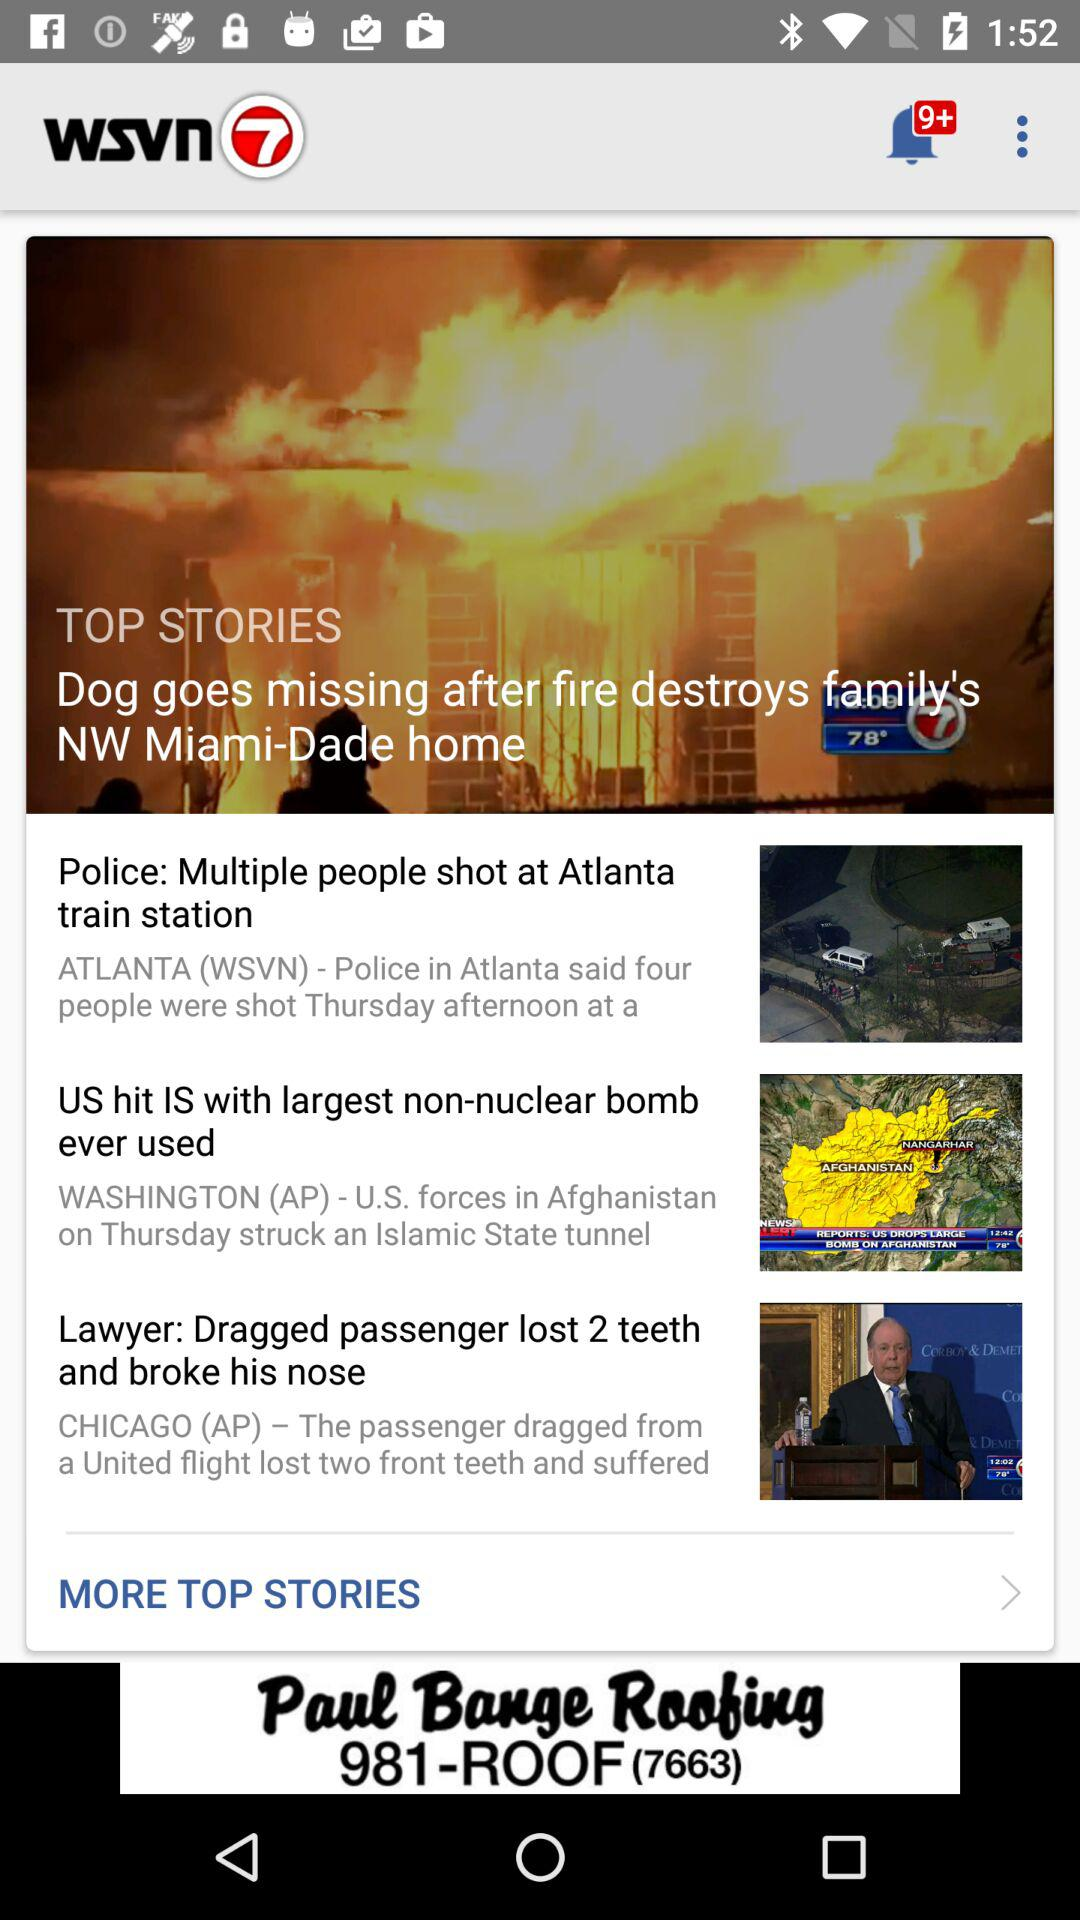What is the headline? The headlines are "Dog goes missing after fire destroys family's NW Miami-Dade home", "Police: Multiple people shot at Atlanta train station", "US hit IS with largest non-nuclear bomb ever used" and "Lawyer: Dragged passenger lost 2 teeth and broke his nose". 